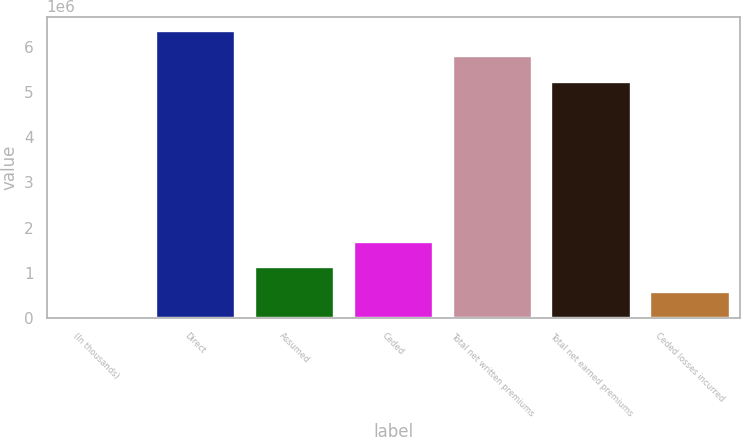Convert chart to OTSL. <chart><loc_0><loc_0><loc_500><loc_500><bar_chart><fcel>(In thousands)<fcel>Direct<fcel>Assumed<fcel>Ceded<fcel>Total net written premiums<fcel>Total net earned premiums<fcel>Ceded losses incurred<nl><fcel>2013<fcel>6.35137e+06<fcel>1.12684e+06<fcel>1.68926e+06<fcel>5.78895e+06<fcel>5.22654e+06<fcel>564429<nl></chart> 